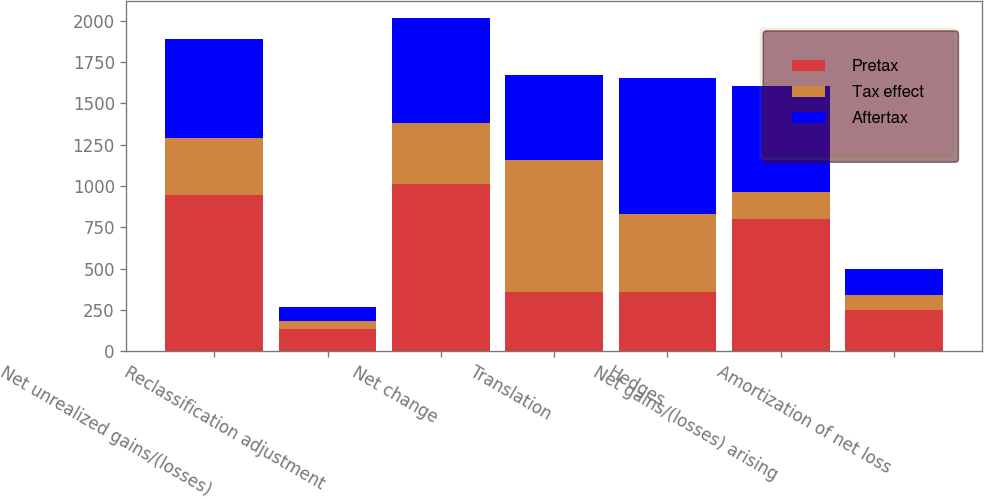<chart> <loc_0><loc_0><loc_500><loc_500><stacked_bar_chart><ecel><fcel>Net unrealized gains/(losses)<fcel>Reclassification adjustment<fcel>Net change<fcel>Translation<fcel>Hedges<fcel>Net gains/(losses) arising<fcel>Amortization of net loss<nl><fcel>Pretax<fcel>944<fcel>134<fcel>1010<fcel>358<fcel>358<fcel>802<fcel>250<nl><fcel>Tax effect<fcel>346<fcel>50<fcel>370<fcel>801<fcel>476<fcel>160<fcel>90<nl><fcel>Aftertax<fcel>598<fcel>84<fcel>640<fcel>512<fcel>818<fcel>642<fcel>160<nl></chart> 